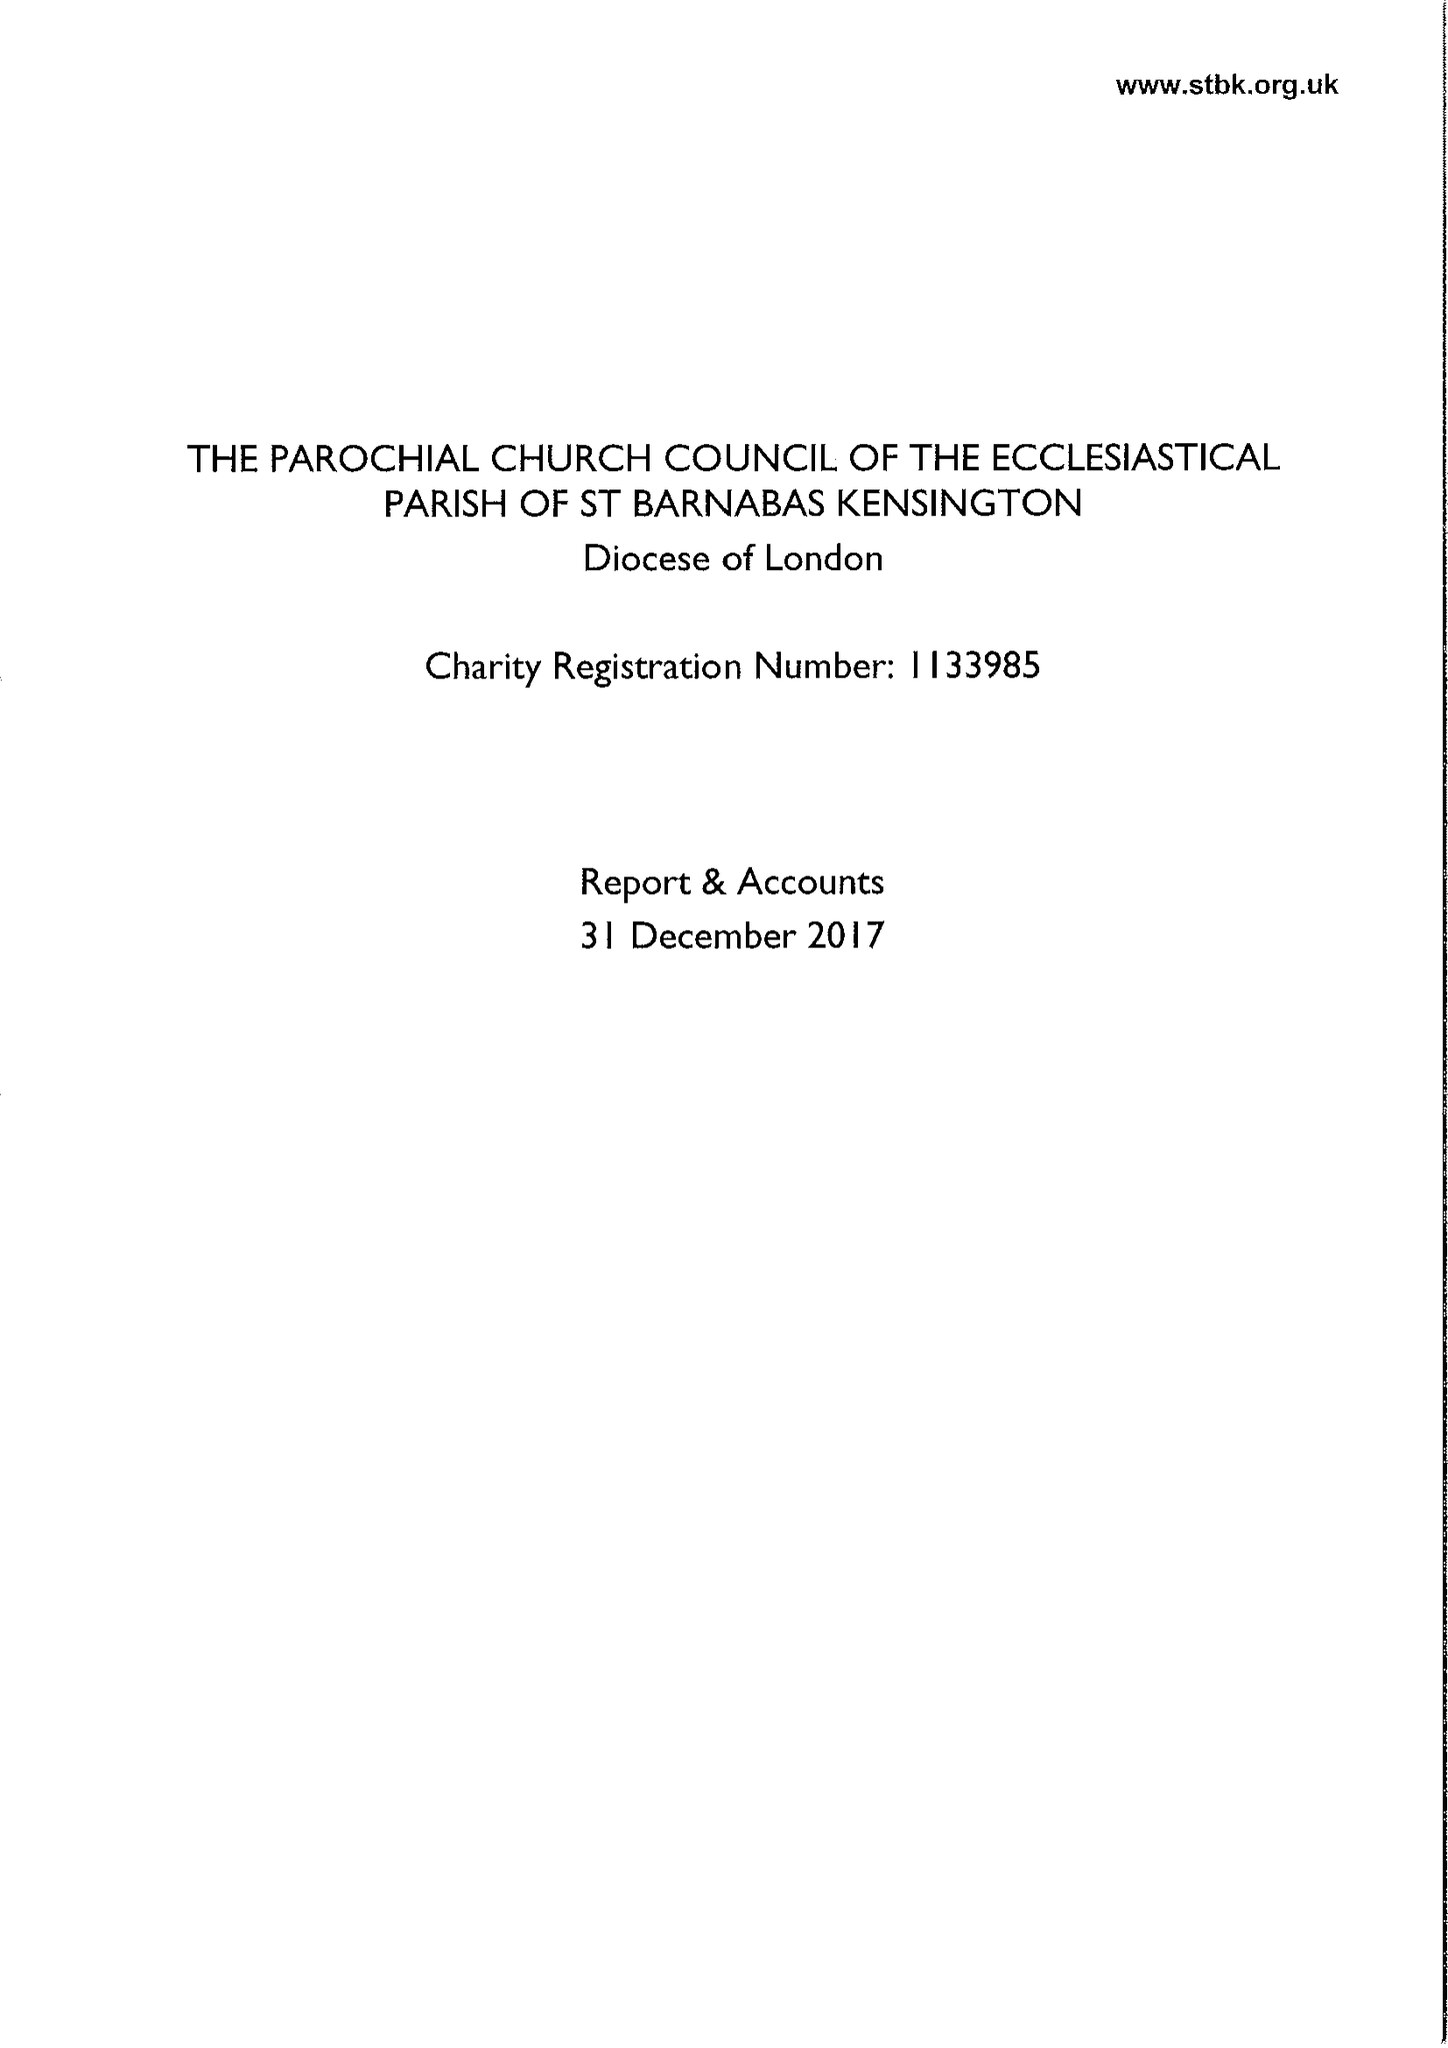What is the value for the address__street_line?
Answer the question using a single word or phrase. 23 ADDISON ROAD 